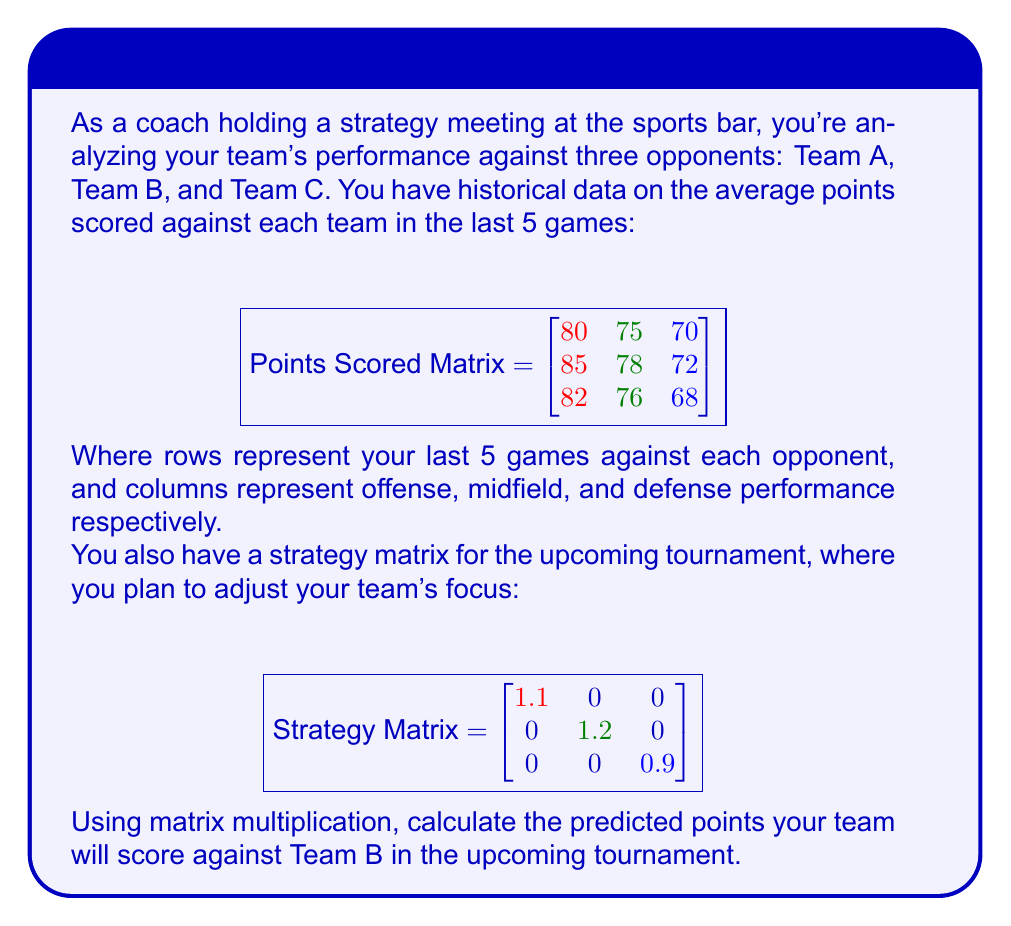Teach me how to tackle this problem. Let's approach this step-by-step:

1) First, we need to identify the relevant data for Team B. This is the second row of the Points Scored Matrix:

   $$[85 \quad 78 \quad 72]$$

2) To predict the new scores, we need to multiply this row by the Strategy Matrix. The calculation will be:

   $$[85 \quad 78 \quad 72] \times \begin{bmatrix}
   1.1 & 0 & 0 \\
   0 & 1.2 & 0 \\
   0 & 0 & 0.9
   \end{bmatrix}$$

3) Let's perform the matrix multiplication:

   $$(85 \times 1.1) + (78 \times 0) + (72 \times 0) = 93.5$$
   $$(85 \times 0) + (78 \times 1.2) + (72 \times 0) = 93.6$$
   $$(85 \times 0) + (78 \times 0) + (72 \times 0.9) = 64.8$$

4) The result is a new row vector:

   $$[93.5 \quad 93.6 \quad 64.8]$$

5) To get the total predicted points, we sum these values:

   $$93.5 + 93.6 + 64.8 = 251.9$$

Therefore, the predicted points your team will score against Team B in the upcoming tournament is 251.9.
Answer: 251.9 points 